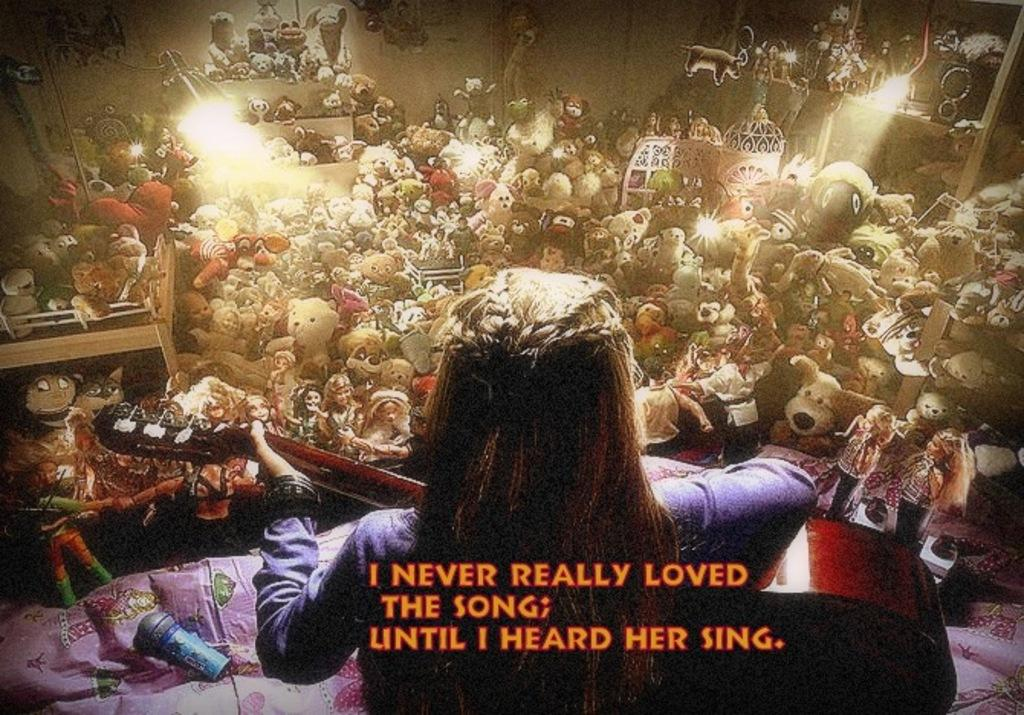Who is the main subject in the image? There is a woman in the image. What is the woman holding in the image? The woman is holding a guitar. What can be seen in the background of the image? There are toys and lights visible in the background of the image. Is there any text or writing present in the image? Yes, there is text or writing visible on the image. What type of dress is the woman wearing in the image? The provided facts do not mention any dress worn by the woman in the image. --- Facts: 1. There is a car in the image. 2. The car is parked on the street. 3. There are trees in the background of the image. 4. The sky is visible in the image. 5. There is a traffic light near the car. Absurd Topics: parrot, sand, volcano Conversation: What is the main subject in the image? There is a car in the image. Where is the car located in the image? The car is parked on the street. What can be seen in the background of the image? There are trees and the sky visible in the image. Is there any traffic control device near the car? Yes, there is a traffic light near the car. Reasoning: Let's think step by step in order to produce the conversation. We start by identifying the main subject in the image, which is the car. Then, we expand the conversation to include other items that are also visible, such as the street, trees, sky, and traffic light. Each question is designed to elicit a specific detail about the image that is known from the provided facts. Absurd Question/Answer: Can you see a parrot sitting on the car in the image? No, there is no parrot present in the image. --- Facts: 1. There is a group of people in the image. 2. The people are wearing hats. 3. There is a table in the image. 4. The table has food on it. 5. There are chairs around the table. Absurd Topics: fish, mountain, bicycle Conversation: Who is the main subject in the image? There is a group of people in the image. What are the people wearing in the image? The people are wearing hats in the image. What can be seen in the image besides the people? There is a table with food on it and chairs around the table in the image. Reasoning: Let's think step by step in order to produce the conversation. We start by identifying the main subject in the image, which is the group of people. Then, we expand the conversation to include other items that are also visible, such as the hats, table, food, and chairs. Each question is designed to elicit a specific detail about the image 